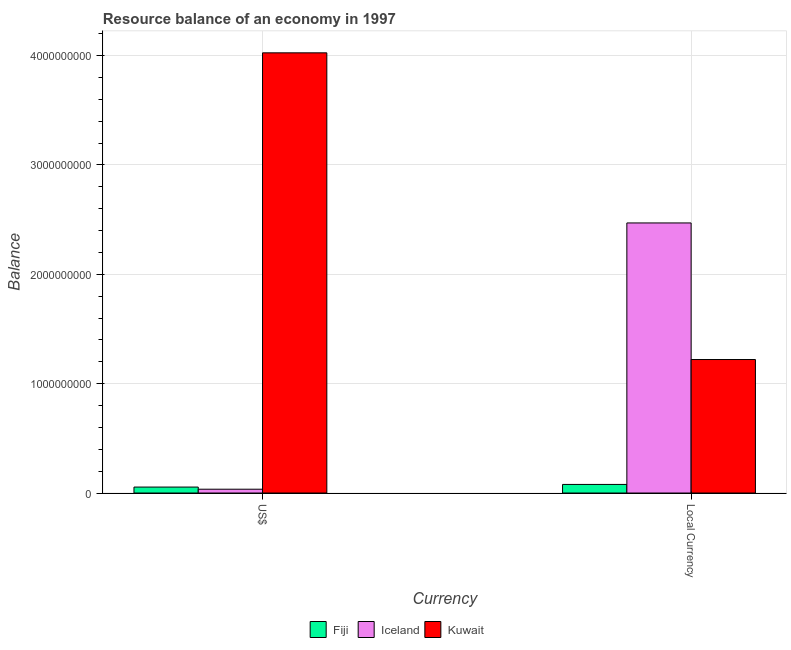How many different coloured bars are there?
Offer a very short reply. 3. How many bars are there on the 2nd tick from the right?
Make the answer very short. 3. What is the label of the 2nd group of bars from the left?
Make the answer very short. Local Currency. What is the resource balance in us$ in Iceland?
Give a very brief answer. 3.48e+07. Across all countries, what is the maximum resource balance in constant us$?
Give a very brief answer. 2.47e+09. Across all countries, what is the minimum resource balance in us$?
Ensure brevity in your answer.  3.48e+07. In which country was the resource balance in constant us$ maximum?
Offer a very short reply. Iceland. In which country was the resource balance in us$ minimum?
Provide a short and direct response. Iceland. What is the total resource balance in constant us$ in the graph?
Offer a very short reply. 3.77e+09. What is the difference between the resource balance in constant us$ in Kuwait and that in Iceland?
Provide a succinct answer. -1.25e+09. What is the difference between the resource balance in constant us$ in Kuwait and the resource balance in us$ in Iceland?
Provide a short and direct response. 1.19e+09. What is the average resource balance in constant us$ per country?
Your response must be concise. 1.26e+09. What is the difference between the resource balance in constant us$ and resource balance in us$ in Fiji?
Your answer should be very brief. 2.42e+07. What is the ratio of the resource balance in constant us$ in Iceland to that in Fiji?
Ensure brevity in your answer.  31.42. Is the resource balance in us$ in Kuwait less than that in Iceland?
Offer a very short reply. No. What does the 3rd bar from the right in US$ represents?
Provide a succinct answer. Fiji. How many bars are there?
Your answer should be compact. 6. How many countries are there in the graph?
Keep it short and to the point. 3. Are the values on the major ticks of Y-axis written in scientific E-notation?
Your answer should be compact. No. Does the graph contain any zero values?
Your answer should be very brief. No. Does the graph contain grids?
Your response must be concise. Yes. Where does the legend appear in the graph?
Your response must be concise. Bottom center. What is the title of the graph?
Provide a short and direct response. Resource balance of an economy in 1997. Does "Vanuatu" appear as one of the legend labels in the graph?
Provide a succinct answer. No. What is the label or title of the X-axis?
Provide a short and direct response. Currency. What is the label or title of the Y-axis?
Your answer should be compact. Balance. What is the Balance in Fiji in US$?
Make the answer very short. 5.44e+07. What is the Balance of Iceland in US$?
Give a very brief answer. 3.48e+07. What is the Balance of Kuwait in US$?
Provide a succinct answer. 4.03e+09. What is the Balance of Fiji in Local Currency?
Your answer should be compact. 7.86e+07. What is the Balance in Iceland in Local Currency?
Ensure brevity in your answer.  2.47e+09. What is the Balance of Kuwait in Local Currency?
Provide a succinct answer. 1.22e+09. Across all Currency, what is the maximum Balance of Fiji?
Offer a terse response. 7.86e+07. Across all Currency, what is the maximum Balance in Iceland?
Offer a terse response. 2.47e+09. Across all Currency, what is the maximum Balance in Kuwait?
Give a very brief answer. 4.03e+09. Across all Currency, what is the minimum Balance in Fiji?
Make the answer very short. 5.44e+07. Across all Currency, what is the minimum Balance of Iceland?
Offer a very short reply. 3.48e+07. Across all Currency, what is the minimum Balance in Kuwait?
Offer a very short reply. 1.22e+09. What is the total Balance in Fiji in the graph?
Your response must be concise. 1.33e+08. What is the total Balance in Iceland in the graph?
Offer a very short reply. 2.50e+09. What is the total Balance of Kuwait in the graph?
Your answer should be very brief. 5.25e+09. What is the difference between the Balance of Fiji in US$ and that in Local Currency?
Ensure brevity in your answer.  -2.42e+07. What is the difference between the Balance in Iceland in US$ and that in Local Currency?
Ensure brevity in your answer.  -2.44e+09. What is the difference between the Balance of Kuwait in US$ and that in Local Currency?
Your answer should be compact. 2.80e+09. What is the difference between the Balance of Fiji in US$ and the Balance of Iceland in Local Currency?
Keep it short and to the point. -2.42e+09. What is the difference between the Balance in Fiji in US$ and the Balance in Kuwait in Local Currency?
Provide a short and direct response. -1.17e+09. What is the difference between the Balance of Iceland in US$ and the Balance of Kuwait in Local Currency?
Provide a short and direct response. -1.19e+09. What is the average Balance of Fiji per Currency?
Offer a very short reply. 6.65e+07. What is the average Balance of Iceland per Currency?
Your answer should be very brief. 1.25e+09. What is the average Balance of Kuwait per Currency?
Your answer should be very brief. 2.62e+09. What is the difference between the Balance of Fiji and Balance of Iceland in US$?
Offer a very short reply. 1.96e+07. What is the difference between the Balance in Fiji and Balance in Kuwait in US$?
Provide a short and direct response. -3.97e+09. What is the difference between the Balance of Iceland and Balance of Kuwait in US$?
Give a very brief answer. -3.99e+09. What is the difference between the Balance of Fiji and Balance of Iceland in Local Currency?
Your answer should be very brief. -2.39e+09. What is the difference between the Balance in Fiji and Balance in Kuwait in Local Currency?
Your response must be concise. -1.14e+09. What is the difference between the Balance in Iceland and Balance in Kuwait in Local Currency?
Your response must be concise. 1.25e+09. What is the ratio of the Balance in Fiji in US$ to that in Local Currency?
Provide a succinct answer. 0.69. What is the ratio of the Balance of Iceland in US$ to that in Local Currency?
Your response must be concise. 0.01. What is the ratio of the Balance in Kuwait in US$ to that in Local Currency?
Offer a terse response. 3.3. What is the difference between the highest and the second highest Balance of Fiji?
Provide a short and direct response. 2.42e+07. What is the difference between the highest and the second highest Balance in Iceland?
Give a very brief answer. 2.44e+09. What is the difference between the highest and the second highest Balance of Kuwait?
Provide a succinct answer. 2.80e+09. What is the difference between the highest and the lowest Balance of Fiji?
Your response must be concise. 2.42e+07. What is the difference between the highest and the lowest Balance in Iceland?
Offer a very short reply. 2.44e+09. What is the difference between the highest and the lowest Balance in Kuwait?
Ensure brevity in your answer.  2.80e+09. 